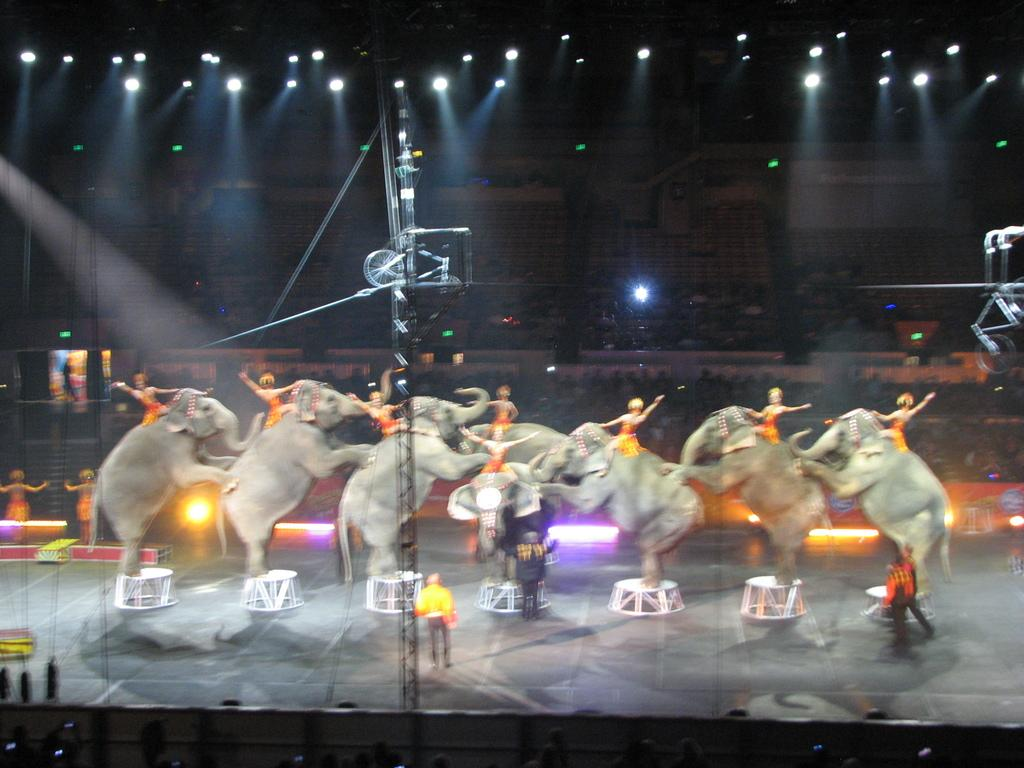What animals are present in the image? There are elephants in the image. What are the people in the image doing with the elephants? People are sitting on the elephants. Who is observing the scene in the image? There is an audience in the image. What can be seen in the image that provides illumination? There is light in the image. What objects can be seen in the image that are used for support or guidance? There is a rope and a stool in the image. What type of zipper can be seen on the elephant's back in the image? There is no zipper present on the elephant's back in the image. 